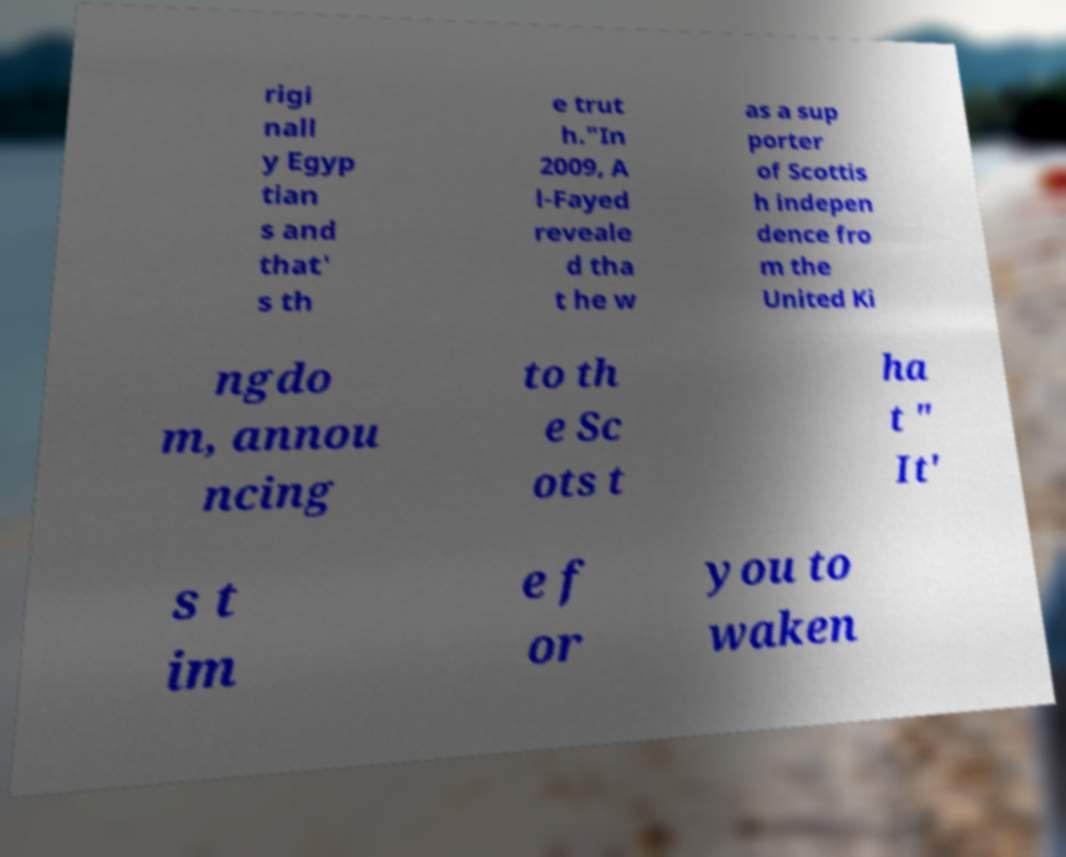There's text embedded in this image that I need extracted. Can you transcribe it verbatim? rigi nall y Egyp tian s and that' s th e trut h."In 2009, A l-Fayed reveale d tha t he w as a sup porter of Scottis h indepen dence fro m the United Ki ngdo m, annou ncing to th e Sc ots t ha t " It' s t im e f or you to waken 